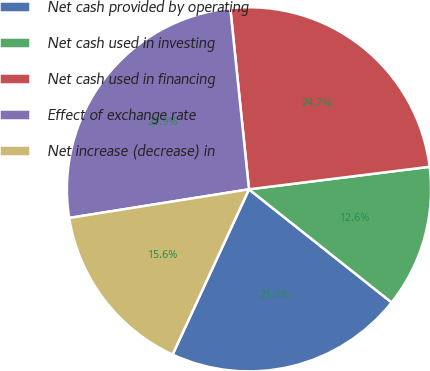Convert chart to OTSL. <chart><loc_0><loc_0><loc_500><loc_500><pie_chart><fcel>Net cash provided by operating<fcel>Net cash used in investing<fcel>Net cash used in financing<fcel>Effect of exchange rate<fcel>Net increase (decrease) in<nl><fcel>21.22%<fcel>12.65%<fcel>24.66%<fcel>25.88%<fcel>15.59%<nl></chart> 